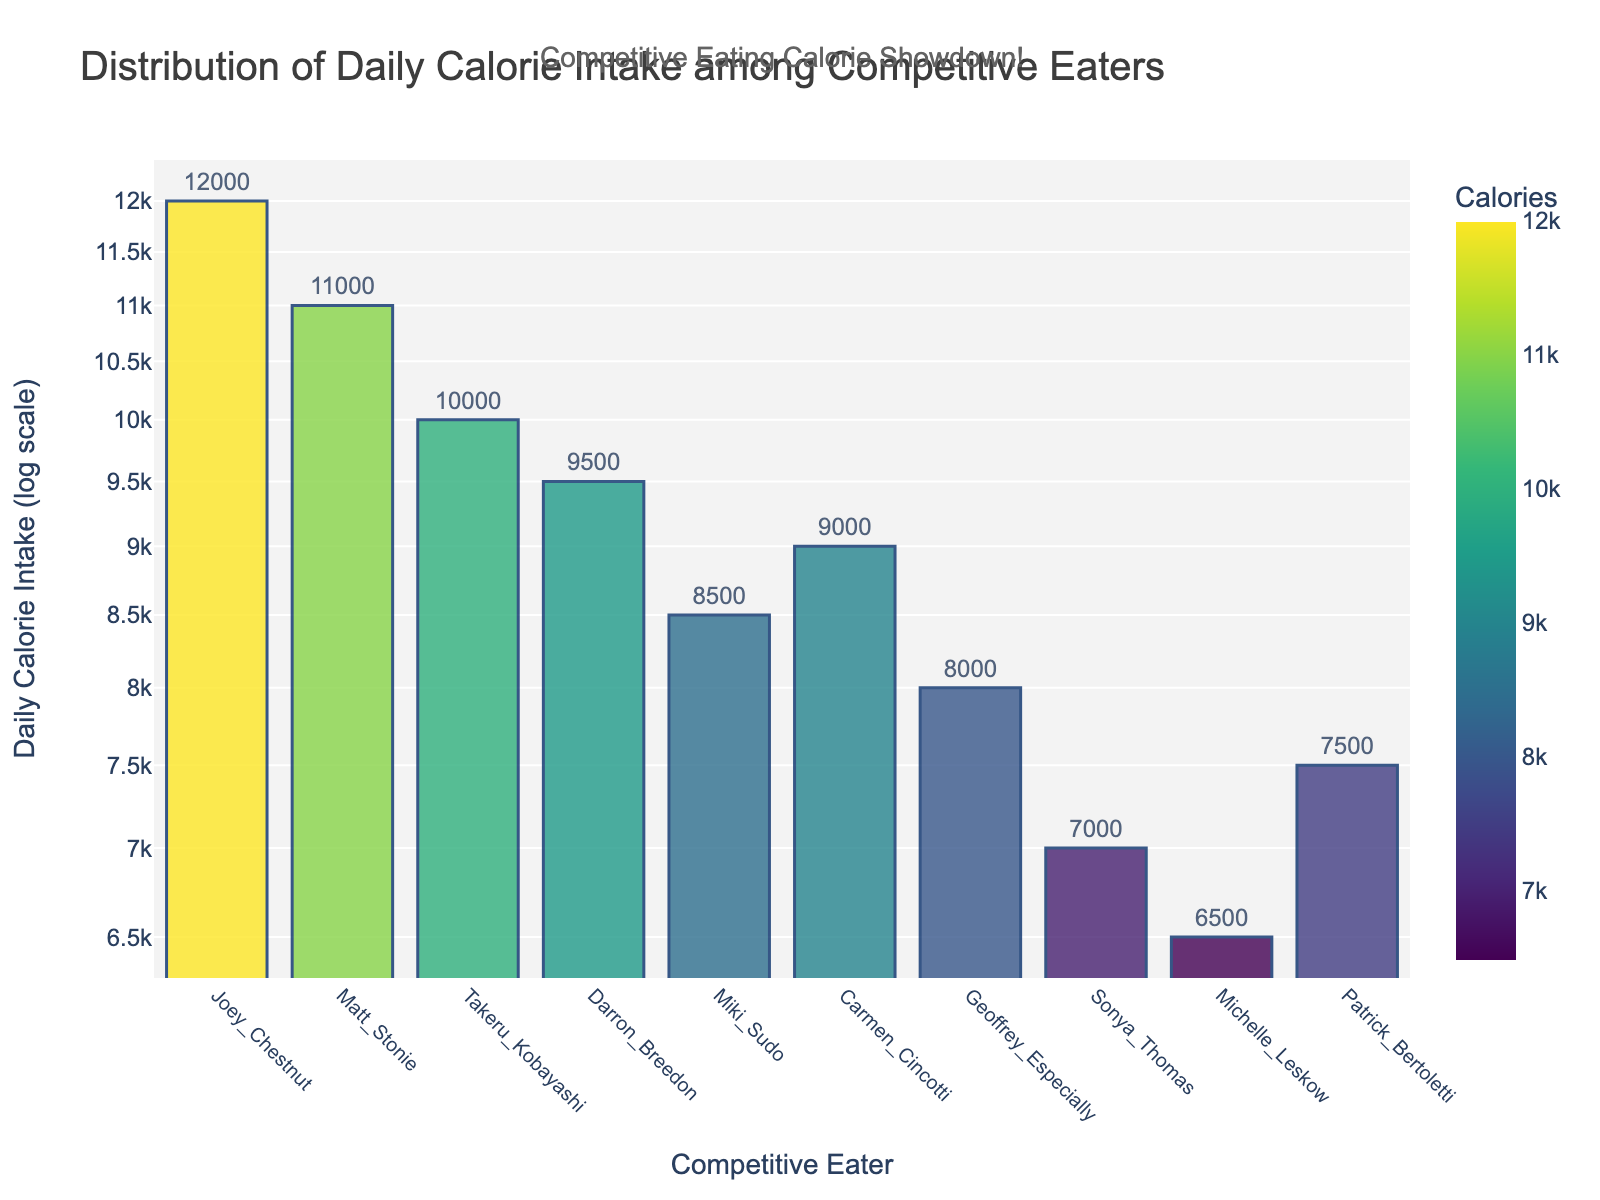Which competitive eater has the highest daily calorie intake? The title of the plot indicates that it shows the distribution of daily calorie intakes among competitive eaters. From the vertical bars, Joey Chestnut has the tallest bar indicating the highest calorie intake.
Answer: Joey Chestnut What is the daily calorie intake of Miki Sudo? The bar corresponding to Miki Sudo's name needs to be located. The height of this bar on the logarithmic y-axis indicates the value, which is 8500.
Answer: 8500 How many competitive eaters have a daily calorie intake of more than 9000? Count the number of bars that exceed the horizontal line marking 9000 on the y-axis. Joey Chestnut, Matt Stonie, Takeru Kobayashi, and Darron Breedon all have intakes over 9000. There are four such competitive eaters.
Answer: 4 What is the difference in daily calorie intake between Joey Chestnut and Geoffrey Especially? Joey Chestnut’s intake is 12000 and Geoffrey Especially’s intake is 8000. Subtracting the latter from the former gives 12000 - 8000 = 4000.
Answer: 4000 Which competitive eater has the lowest daily calorie intake? From the figure, the shortest bar represents the lowest intake. This bar is for Michelle Leskow.
Answer: Michelle Leskow What is the range of daily calorie intakes among the competitive eaters? The range is found by subtracting the lowest intake from the highest. Joey Chestnut has the highest intake at 12000, and Michelle Leskow has the lowest at 6500. Therefore, the range is 12000 - 6500 = 5500.
Answer: 5500 What is the median daily calorie intake among the competitive eaters? With 10 competitive eaters, the median is the average of the 5th and 6th values when sorted from lowest to highest. Sorting the values: 6500, 7000, 7500, 8000, 8500, 9000, 9500, 10000, 11000, 12000. The median is (8500 + 9000) / 2 = 8750.
Answer: 8750 How does the daily calorie intake of Matt Stonie compare to that of Takeru Kobayashi? Both intakes need to be identified from the plot. Matt Stonie's intake is 11000, and Takeru Kobayashi's is 10000. Since 11000 is greater than 10000, Matt Stonie consumes more.
Answer: Matt Stonie consumes more Which competitive eaters consume more than 7000 calories daily but less than 9000 calories daily? Identify and list the competitive eaters whose bars fall between the horizontal lines for 7000 and 9000 on the y-axis. Geoffrey Especially (8000), Patrick Bertoletti (7500), and Sonya Thomas (7000) meet the criteria.
Answer: Geoffrey Especially, Patrick Bertoletti, Sonya Thomas What special note is displayed on the plot? The figure includes an annotation for additional context. This note appears above the chart. It states: "Competitive Eating Calorie Showdown!"
Answer: Competitive Eating Calorie Showdown! 